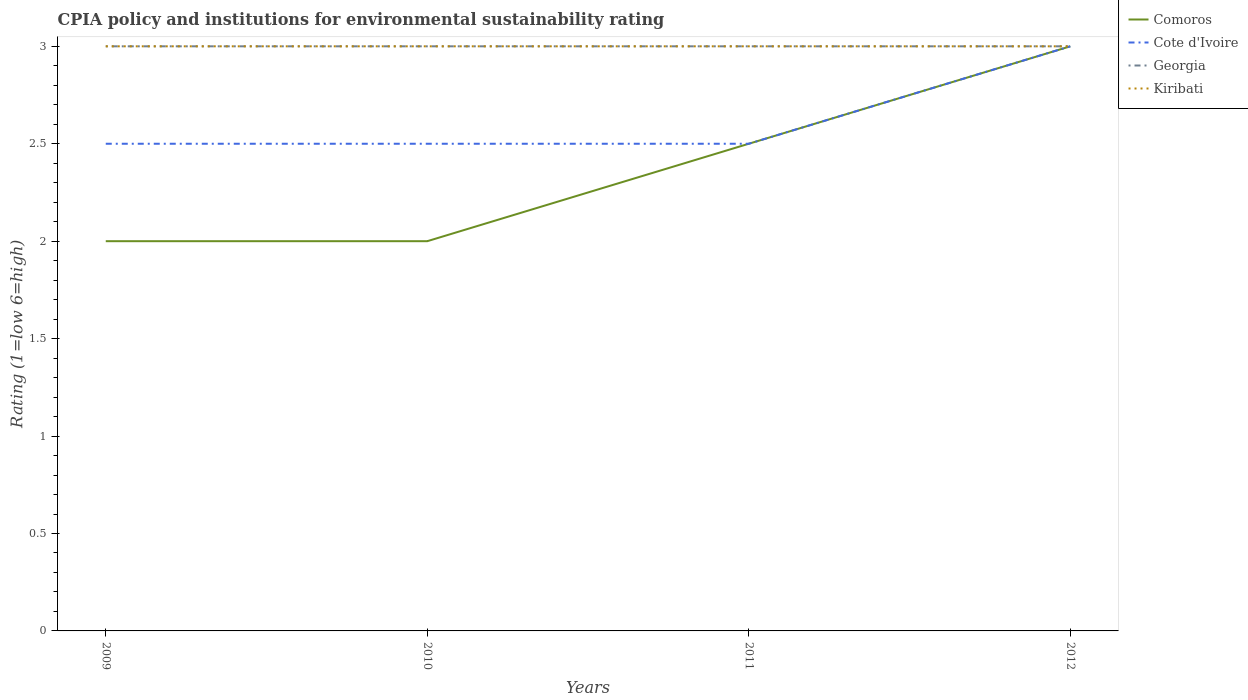Does the line corresponding to Georgia intersect with the line corresponding to Kiribati?
Offer a terse response. Yes. Across all years, what is the maximum CPIA rating in Kiribati?
Make the answer very short. 3. In which year was the CPIA rating in Kiribati maximum?
Your response must be concise. 2009. What is the total CPIA rating in Kiribati in the graph?
Offer a terse response. 0. What is the difference between the highest and the second highest CPIA rating in Kiribati?
Provide a succinct answer. 0. Is the CPIA rating in Kiribati strictly greater than the CPIA rating in Cote d'Ivoire over the years?
Provide a succinct answer. No. How many lines are there?
Offer a very short reply. 4. What is the difference between two consecutive major ticks on the Y-axis?
Your response must be concise. 0.5. Does the graph contain grids?
Your answer should be compact. No. Where does the legend appear in the graph?
Offer a terse response. Top right. What is the title of the graph?
Give a very brief answer. CPIA policy and institutions for environmental sustainability rating. Does "Antigua and Barbuda" appear as one of the legend labels in the graph?
Your answer should be compact. No. What is the Rating (1=low 6=high) in Comoros in 2009?
Your answer should be compact. 2. What is the Rating (1=low 6=high) in Georgia in 2009?
Offer a very short reply. 3. What is the Rating (1=low 6=high) in Comoros in 2010?
Your answer should be compact. 2. What is the Rating (1=low 6=high) of Kiribati in 2010?
Your answer should be compact. 3. What is the Rating (1=low 6=high) of Georgia in 2011?
Your answer should be very brief. 3. What is the Rating (1=low 6=high) of Cote d'Ivoire in 2012?
Provide a short and direct response. 3. What is the Rating (1=low 6=high) in Georgia in 2012?
Give a very brief answer. 3. What is the Rating (1=low 6=high) of Kiribati in 2012?
Make the answer very short. 3. Across all years, what is the maximum Rating (1=low 6=high) of Comoros?
Your answer should be very brief. 3. Across all years, what is the maximum Rating (1=low 6=high) of Kiribati?
Your answer should be compact. 3. Across all years, what is the minimum Rating (1=low 6=high) in Comoros?
Your answer should be compact. 2. Across all years, what is the minimum Rating (1=low 6=high) in Kiribati?
Offer a terse response. 3. What is the total Rating (1=low 6=high) in Comoros in the graph?
Your response must be concise. 9.5. What is the total Rating (1=low 6=high) in Cote d'Ivoire in the graph?
Provide a short and direct response. 10.5. What is the total Rating (1=low 6=high) of Kiribati in the graph?
Your answer should be compact. 12. What is the difference between the Rating (1=low 6=high) in Comoros in 2009 and that in 2010?
Your answer should be compact. 0. What is the difference between the Rating (1=low 6=high) of Georgia in 2009 and that in 2010?
Provide a short and direct response. 0. What is the difference between the Rating (1=low 6=high) in Kiribati in 2009 and that in 2010?
Your answer should be compact. 0. What is the difference between the Rating (1=low 6=high) in Comoros in 2009 and that in 2011?
Offer a very short reply. -0.5. What is the difference between the Rating (1=low 6=high) of Cote d'Ivoire in 2009 and that in 2011?
Ensure brevity in your answer.  0. What is the difference between the Rating (1=low 6=high) of Kiribati in 2009 and that in 2011?
Keep it short and to the point. 0. What is the difference between the Rating (1=low 6=high) in Comoros in 2009 and that in 2012?
Provide a succinct answer. -1. What is the difference between the Rating (1=low 6=high) of Cote d'Ivoire in 2009 and that in 2012?
Provide a short and direct response. -0.5. What is the difference between the Rating (1=low 6=high) of Georgia in 2009 and that in 2012?
Your answer should be very brief. 0. What is the difference between the Rating (1=low 6=high) of Kiribati in 2009 and that in 2012?
Provide a short and direct response. 0. What is the difference between the Rating (1=low 6=high) in Comoros in 2010 and that in 2011?
Offer a very short reply. -0.5. What is the difference between the Rating (1=low 6=high) in Georgia in 2010 and that in 2011?
Your answer should be compact. 0. What is the difference between the Rating (1=low 6=high) in Kiribati in 2010 and that in 2011?
Keep it short and to the point. 0. What is the difference between the Rating (1=low 6=high) of Comoros in 2011 and that in 2012?
Provide a short and direct response. -0.5. What is the difference between the Rating (1=low 6=high) of Cote d'Ivoire in 2011 and that in 2012?
Your answer should be compact. -0.5. What is the difference between the Rating (1=low 6=high) in Georgia in 2011 and that in 2012?
Make the answer very short. 0. What is the difference between the Rating (1=low 6=high) in Kiribati in 2011 and that in 2012?
Keep it short and to the point. 0. What is the difference between the Rating (1=low 6=high) in Comoros in 2009 and the Rating (1=low 6=high) in Georgia in 2010?
Provide a succinct answer. -1. What is the difference between the Rating (1=low 6=high) in Comoros in 2009 and the Rating (1=low 6=high) in Kiribati in 2010?
Provide a short and direct response. -1. What is the difference between the Rating (1=low 6=high) in Cote d'Ivoire in 2009 and the Rating (1=low 6=high) in Kiribati in 2010?
Offer a very short reply. -0.5. What is the difference between the Rating (1=low 6=high) in Cote d'Ivoire in 2009 and the Rating (1=low 6=high) in Georgia in 2011?
Your response must be concise. -0.5. What is the difference between the Rating (1=low 6=high) of Cote d'Ivoire in 2009 and the Rating (1=low 6=high) of Kiribati in 2011?
Your answer should be very brief. -0.5. What is the difference between the Rating (1=low 6=high) in Comoros in 2009 and the Rating (1=low 6=high) in Georgia in 2012?
Your answer should be compact. -1. What is the difference between the Rating (1=low 6=high) in Comoros in 2009 and the Rating (1=low 6=high) in Kiribati in 2012?
Provide a short and direct response. -1. What is the difference between the Rating (1=low 6=high) of Cote d'Ivoire in 2009 and the Rating (1=low 6=high) of Georgia in 2012?
Your answer should be very brief. -0.5. What is the difference between the Rating (1=low 6=high) in Cote d'Ivoire in 2009 and the Rating (1=low 6=high) in Kiribati in 2012?
Your answer should be compact. -0.5. What is the difference between the Rating (1=low 6=high) of Georgia in 2009 and the Rating (1=low 6=high) of Kiribati in 2012?
Make the answer very short. 0. What is the difference between the Rating (1=low 6=high) of Cote d'Ivoire in 2010 and the Rating (1=low 6=high) of Georgia in 2011?
Give a very brief answer. -0.5. What is the difference between the Rating (1=low 6=high) in Georgia in 2010 and the Rating (1=low 6=high) in Kiribati in 2011?
Provide a succinct answer. 0. What is the difference between the Rating (1=low 6=high) in Comoros in 2010 and the Rating (1=low 6=high) in Cote d'Ivoire in 2012?
Your answer should be compact. -1. What is the difference between the Rating (1=low 6=high) of Comoros in 2010 and the Rating (1=low 6=high) of Georgia in 2012?
Your answer should be very brief. -1. What is the difference between the Rating (1=low 6=high) in Comoros in 2010 and the Rating (1=low 6=high) in Kiribati in 2012?
Give a very brief answer. -1. What is the difference between the Rating (1=low 6=high) in Cote d'Ivoire in 2010 and the Rating (1=low 6=high) in Georgia in 2012?
Keep it short and to the point. -0.5. What is the difference between the Rating (1=low 6=high) in Comoros in 2011 and the Rating (1=low 6=high) in Georgia in 2012?
Your answer should be compact. -0.5. What is the difference between the Rating (1=low 6=high) of Comoros in 2011 and the Rating (1=low 6=high) of Kiribati in 2012?
Your response must be concise. -0.5. What is the difference between the Rating (1=low 6=high) of Cote d'Ivoire in 2011 and the Rating (1=low 6=high) of Georgia in 2012?
Offer a very short reply. -0.5. What is the difference between the Rating (1=low 6=high) of Georgia in 2011 and the Rating (1=low 6=high) of Kiribati in 2012?
Offer a terse response. 0. What is the average Rating (1=low 6=high) in Comoros per year?
Offer a very short reply. 2.38. What is the average Rating (1=low 6=high) in Cote d'Ivoire per year?
Your answer should be compact. 2.62. What is the average Rating (1=low 6=high) in Georgia per year?
Ensure brevity in your answer.  3. In the year 2009, what is the difference between the Rating (1=low 6=high) in Comoros and Rating (1=low 6=high) in Kiribati?
Provide a succinct answer. -1. In the year 2009, what is the difference between the Rating (1=low 6=high) of Cote d'Ivoire and Rating (1=low 6=high) of Georgia?
Make the answer very short. -0.5. In the year 2009, what is the difference between the Rating (1=low 6=high) in Cote d'Ivoire and Rating (1=low 6=high) in Kiribati?
Keep it short and to the point. -0.5. In the year 2009, what is the difference between the Rating (1=low 6=high) in Georgia and Rating (1=low 6=high) in Kiribati?
Your response must be concise. 0. In the year 2010, what is the difference between the Rating (1=low 6=high) of Comoros and Rating (1=low 6=high) of Cote d'Ivoire?
Give a very brief answer. -0.5. In the year 2011, what is the difference between the Rating (1=low 6=high) in Comoros and Rating (1=low 6=high) in Cote d'Ivoire?
Offer a terse response. 0. In the year 2011, what is the difference between the Rating (1=low 6=high) of Comoros and Rating (1=low 6=high) of Kiribati?
Make the answer very short. -0.5. In the year 2011, what is the difference between the Rating (1=low 6=high) in Cote d'Ivoire and Rating (1=low 6=high) in Georgia?
Your response must be concise. -0.5. In the year 2012, what is the difference between the Rating (1=low 6=high) of Comoros and Rating (1=low 6=high) of Georgia?
Offer a very short reply. 0. In the year 2012, what is the difference between the Rating (1=low 6=high) in Cote d'Ivoire and Rating (1=low 6=high) in Kiribati?
Your answer should be very brief. 0. What is the ratio of the Rating (1=low 6=high) in Comoros in 2009 to that in 2010?
Provide a short and direct response. 1. What is the ratio of the Rating (1=low 6=high) in Georgia in 2009 to that in 2010?
Give a very brief answer. 1. What is the ratio of the Rating (1=low 6=high) of Kiribati in 2009 to that in 2010?
Give a very brief answer. 1. What is the ratio of the Rating (1=low 6=high) in Georgia in 2009 to that in 2011?
Provide a short and direct response. 1. What is the ratio of the Rating (1=low 6=high) of Kiribati in 2009 to that in 2011?
Offer a very short reply. 1. What is the ratio of the Rating (1=low 6=high) of Comoros in 2009 to that in 2012?
Keep it short and to the point. 0.67. What is the ratio of the Rating (1=low 6=high) of Cote d'Ivoire in 2009 to that in 2012?
Your answer should be very brief. 0.83. What is the ratio of the Rating (1=low 6=high) in Cote d'Ivoire in 2010 to that in 2011?
Ensure brevity in your answer.  1. What is the ratio of the Rating (1=low 6=high) in Comoros in 2010 to that in 2012?
Give a very brief answer. 0.67. What is the ratio of the Rating (1=low 6=high) in Georgia in 2010 to that in 2012?
Your answer should be very brief. 1. What is the ratio of the Rating (1=low 6=high) in Kiribati in 2010 to that in 2012?
Ensure brevity in your answer.  1. What is the ratio of the Rating (1=low 6=high) in Comoros in 2011 to that in 2012?
Your response must be concise. 0.83. What is the ratio of the Rating (1=low 6=high) of Cote d'Ivoire in 2011 to that in 2012?
Your answer should be very brief. 0.83. What is the ratio of the Rating (1=low 6=high) in Kiribati in 2011 to that in 2012?
Keep it short and to the point. 1. What is the difference between the highest and the second highest Rating (1=low 6=high) in Georgia?
Offer a very short reply. 0. What is the difference between the highest and the lowest Rating (1=low 6=high) in Comoros?
Provide a short and direct response. 1. 